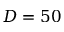<formula> <loc_0><loc_0><loc_500><loc_500>D = 5 0</formula> 